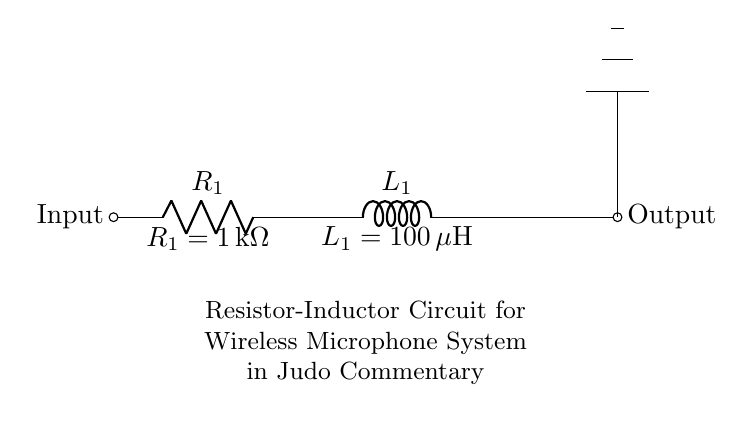What are the components in the circuit? The circuit contains a resistor labeled R1 and an inductor labeled L1.
Answer: Resistor and Inductor What is the value of the resistor R1? The value of resistor R1 is indicated in the circuit as 1 kilo-ohm.
Answer: 1 kilo-ohm What is the value of the inductor L1? The circuit specifies the value of inductor L1 as 100 micro-henries.
Answer: 100 micro-henries How are the components connected in this circuit? The components are connected in series, with R1 directly connected to L1, leading to the output.
Answer: In series Why is a resistor used in this circuit? A resistor is used to limit the current flow and avoid overloading other components in the microphone system.
Answer: To limit current What is the purpose of the inductor in this circuit? The inductor is used to store energy in a magnetic field and can help filter signals in the wireless microphone system.
Answer: To store energy and filter signals How does the combined behavior of resistor and inductor affect the circuit? The resistor and inductor together create a second-order circuit response that can filter out unwanted frequencies, improving signal quality for commentary.
Answer: It filters unwanted frequencies 